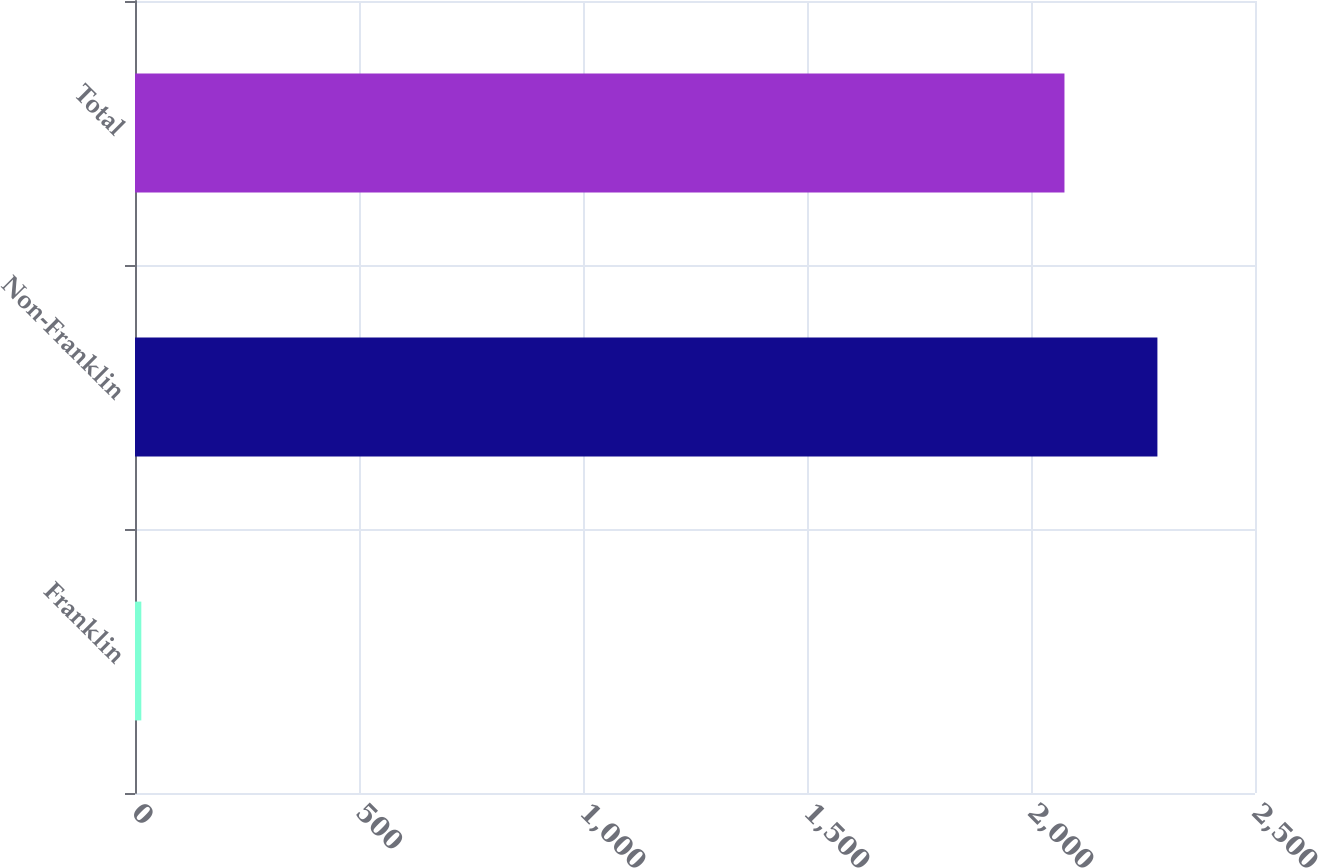<chart> <loc_0><loc_0><loc_500><loc_500><bar_chart><fcel>Franklin<fcel>Non-Franklin<fcel>Total<nl><fcel>14.1<fcel>2282.17<fcel>2074.7<nl></chart> 